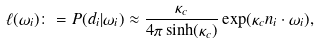Convert formula to latex. <formula><loc_0><loc_0><loc_500><loc_500>\ell ( \omega _ { i } ) \colon = P ( d _ { i } | \omega _ { i } ) \approx \frac { \kappa _ { c } } { 4 \pi \sinh ( \kappa _ { c } ) } \exp ( \kappa _ { c } n _ { i } \cdot \omega _ { i } ) ,</formula> 